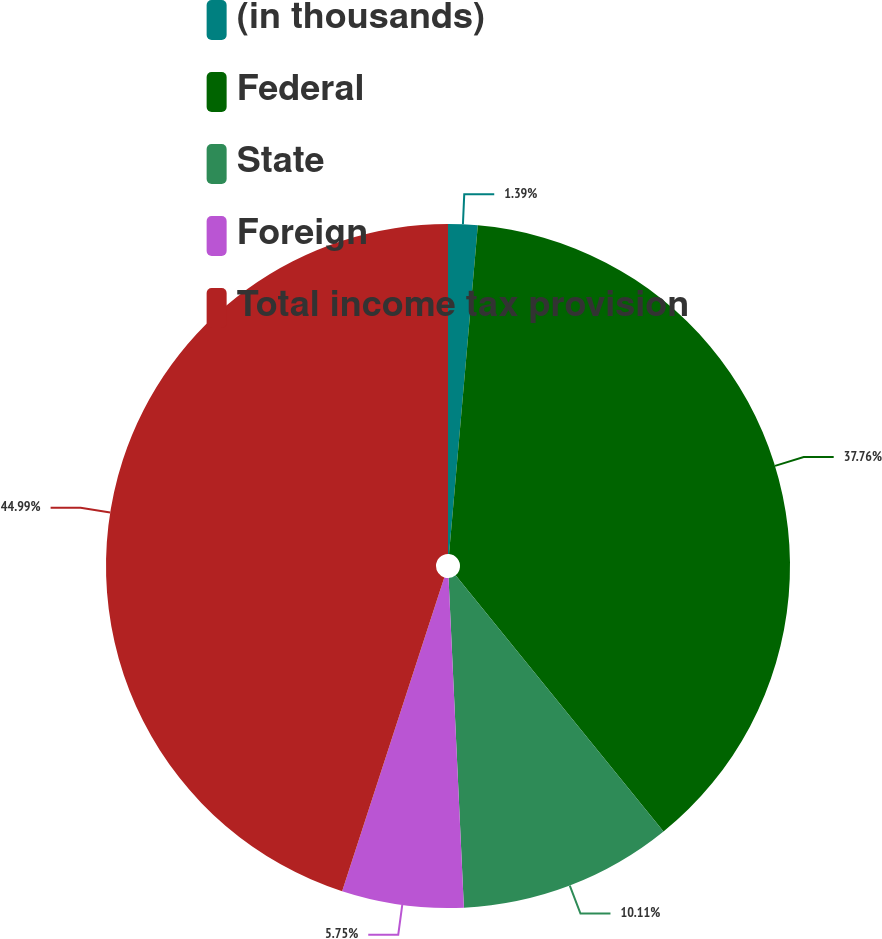Convert chart. <chart><loc_0><loc_0><loc_500><loc_500><pie_chart><fcel>(in thousands)<fcel>Federal<fcel>State<fcel>Foreign<fcel>Total income tax provision<nl><fcel>1.39%<fcel>37.76%<fcel>10.11%<fcel>5.75%<fcel>44.99%<nl></chart> 